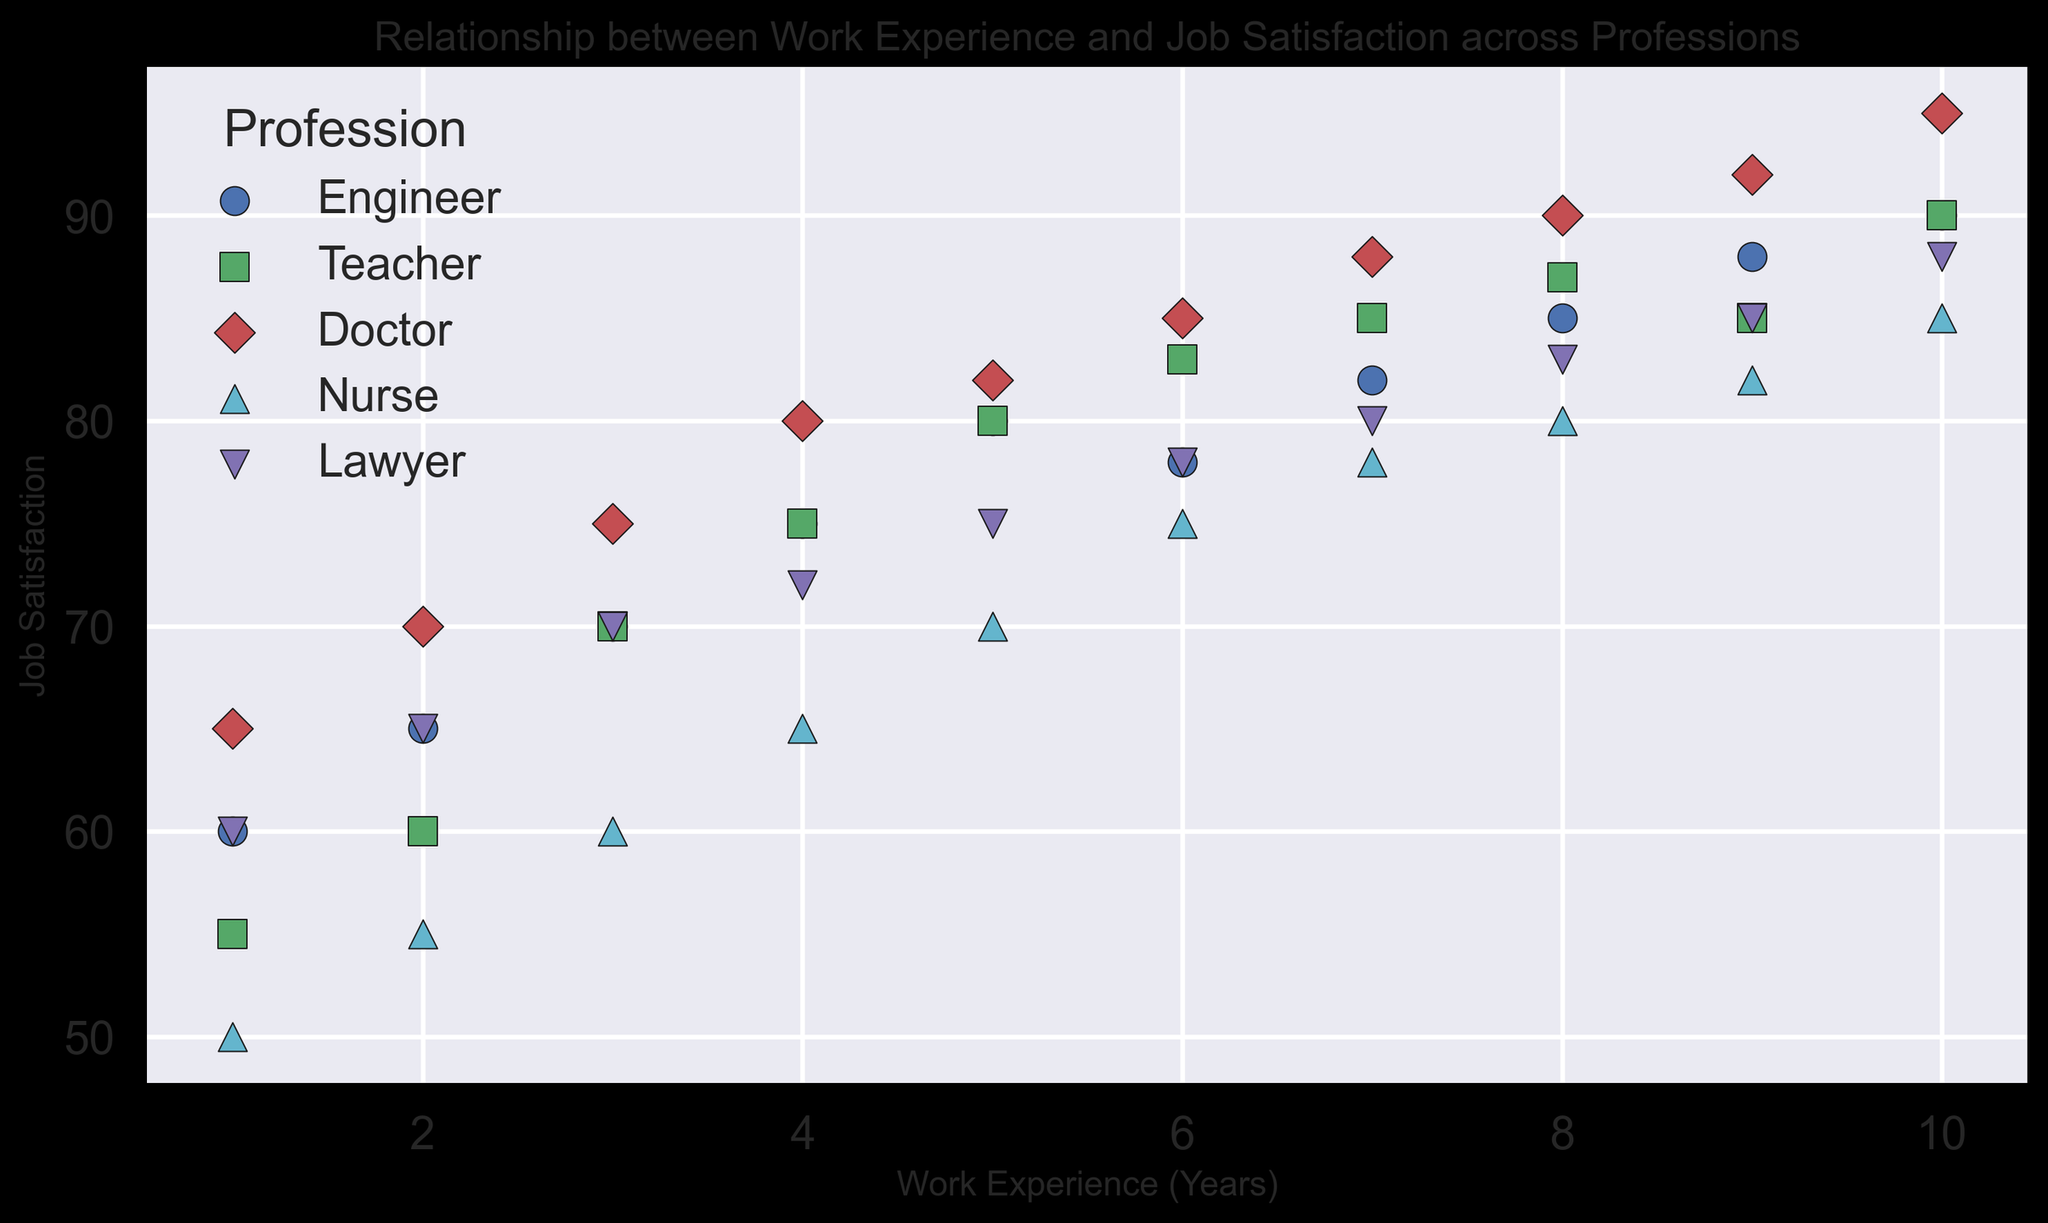What profession shows the highest job satisfaction for ten years of work experience? Look at the data points where work experience is 10 years. Compare job satisfaction scores for different professions. The highest score is obtained by doctors.
Answer: Doctor How does the job satisfaction of teachers compare to that of engineers with the same years of experience? Look at the job satisfaction levels of teachers and engineers for each year of work experience. Generally, teachers have slightly lower or equal job satisfaction compared to engineers in the earlier years, but both reach 90 in 10 years.
Answer: About the same What is the average job satisfaction for engineers over 6 and 7 years of experience? Check the job satisfaction for engineers with 6 and 7 years of experience. Job satisfaction values are 78 and 82. Calculate the average: (78 + 82) / 2 = 80.
Answer: 80 Which profession shows the least improvement in job satisfaction over ten years? Look at the difference in job satisfaction from year 1 to year 10 for each profession. Nurses increase from 50 to 85, i.e., a 35-point improvement, which is the smallest increase among all professions.
Answer: Nurse Which profession has the most varied job satisfaction scores in the first 5 years of experience? Look at the job satisfaction scores for 1 to 5 years of experience for each profession and assess variability. Doctors have a larger range from 65 to 82 in the first 5 years, showing the most variability.
Answer: Doctor Is there any profession where the job satisfaction decreases at any point during the ten years? Observe the trend lines for each profession over 10 years. For all professions, job satisfaction consistently increases over time.
Answer: No What is the combined job satisfaction for teachers and engineers at 4 years of experience? Look at job satisfaction scores for teachers and engineers at 4 years of experience, which are 75 and 75, respectively. Add them together: 75 + 75 = 150.
Answer: 150 Which profession shows a steep increase in job satisfaction between 1 and 5 years? Check the job satisfaction scores from year 1 to year 5. Nurses increase from 50 to 70, indicating a 20-point rise, which is quite steep.
Answer: Nurse For which profession does job satisfaction plateau towards the end of the ten years? Analyze job satisfaction trends over the last 3-4 years for each profession. Engineer's satisfaction increases slightly from 85 to 90, indicating a plateau.
Answer: Engineer 